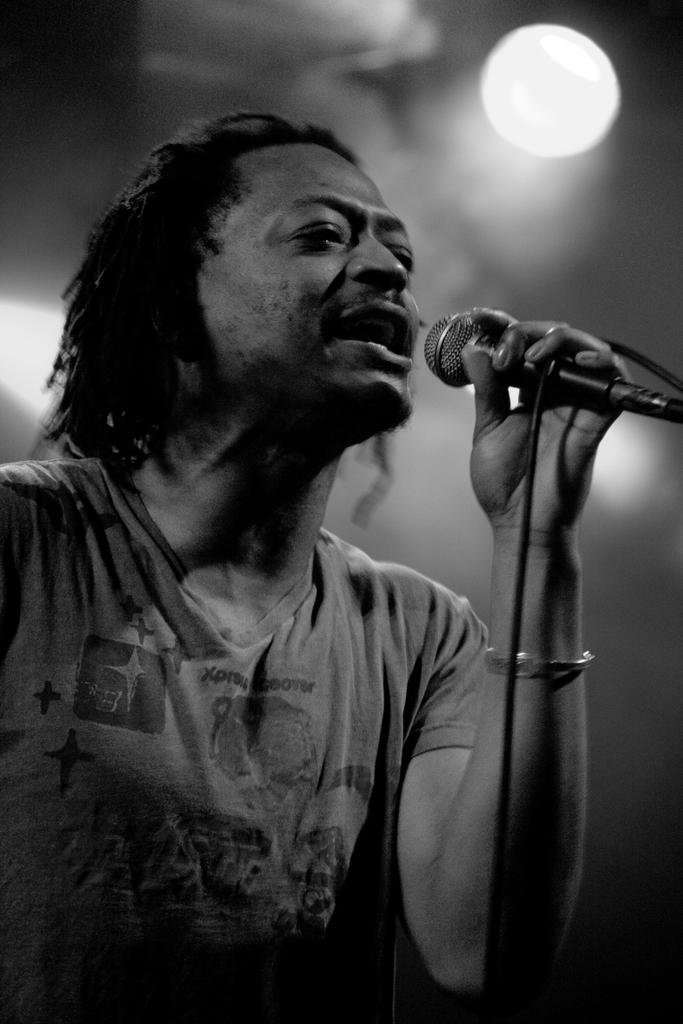What is the man in the image doing? The man is singing in the image. What is the man holding while singing? The man is holding a microphone. What is the man wearing on his upper body? The man is wearing a T-shirt. What can be observed about the man's hair? The man has long hair. How would you describe the background of the image? The background of the image is blurred. What advice is the man's mother giving him about his sleep schedule in the image? There is no mention of the man's mother or his sleep schedule in the image. What type of organization is the man representing in the image? There is no indication of any organization in the image; it simply shows a man singing with a microphone. 